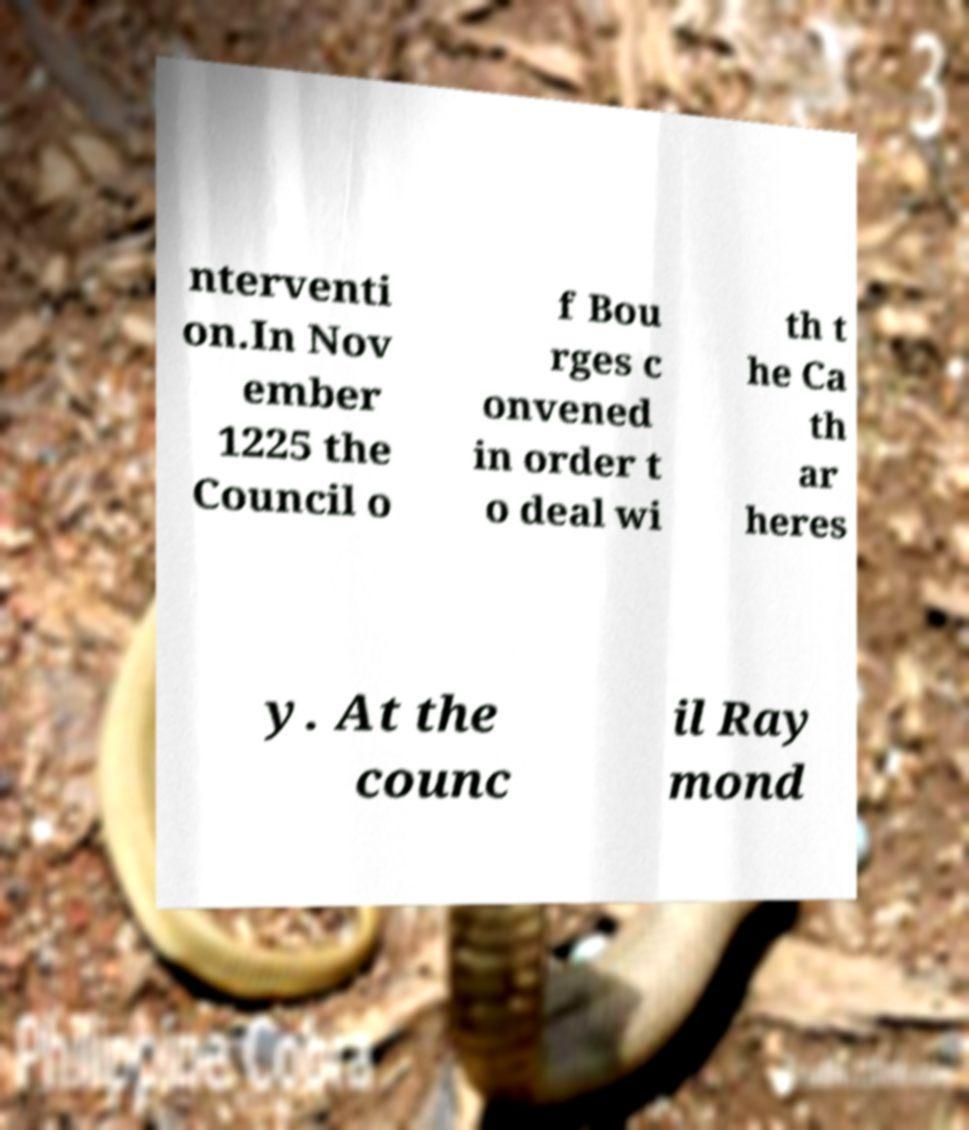Can you read and provide the text displayed in the image?This photo seems to have some interesting text. Can you extract and type it out for me? nterventi on.In Nov ember 1225 the Council o f Bou rges c onvened in order t o deal wi th t he Ca th ar heres y. At the counc il Ray mond 